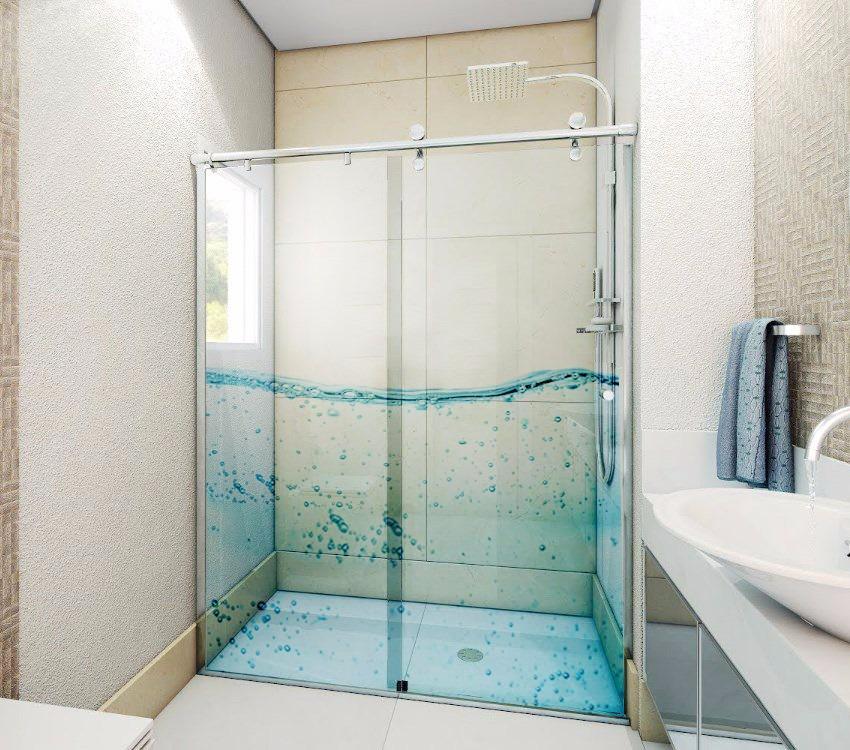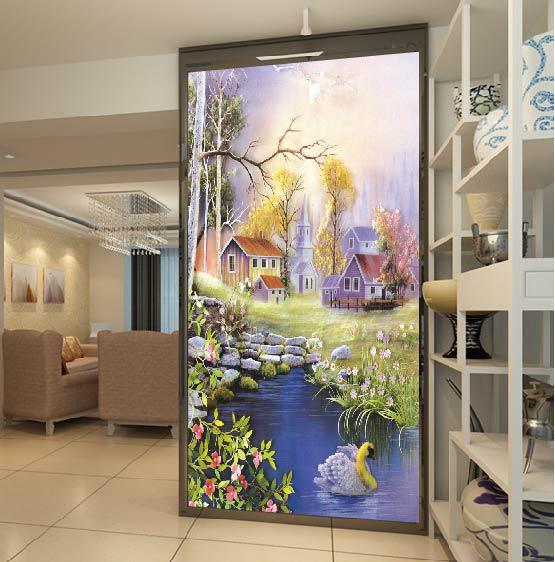The first image is the image on the left, the second image is the image on the right. Assess this claim about the two images: "There are three sheet of glass that are decorated with art and at least one different image.". Correct or not? Answer yes or no. Yes. The first image is the image on the left, the second image is the image on the right. Assess this claim about the two images: "The wall in the right image is decorated with art of only flowers.". Correct or not? Answer yes or no. No. 